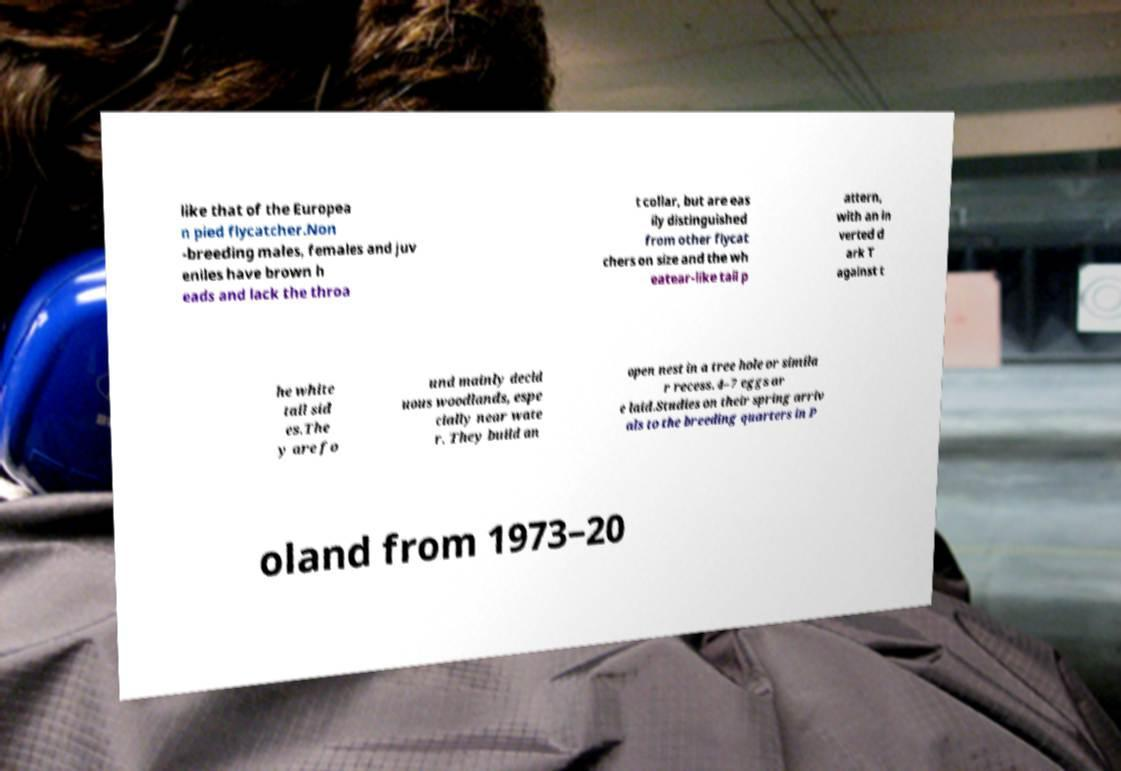For documentation purposes, I need the text within this image transcribed. Could you provide that? like that of the Europea n pied flycatcher.Non -breeding males, females and juv eniles have brown h eads and lack the throa t collar, but are eas ily distinguished from other flycat chers on size and the wh eatear-like tail p attern, with an in verted d ark T against t he white tail sid es.The y are fo und mainly decid uous woodlands, espe cially near wate r. They build an open nest in a tree hole or simila r recess. 4–7 eggs ar e laid.Studies on their spring arriv als to the breeding quarters in P oland from 1973–20 